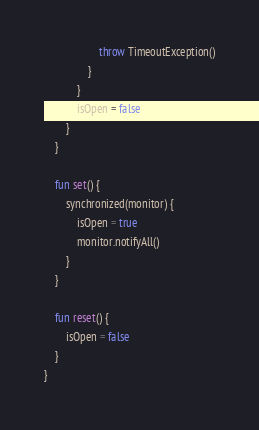Convert code to text. <code><loc_0><loc_0><loc_500><loc_500><_Kotlin_>                    throw TimeoutException()
                }
            }
            isOpen = false
        }
    }

    fun set() {
        synchronized(monitor) {
            isOpen = true
            monitor.notifyAll()
        }
    }

    fun reset() {
        isOpen = false
    }
}
</code> 